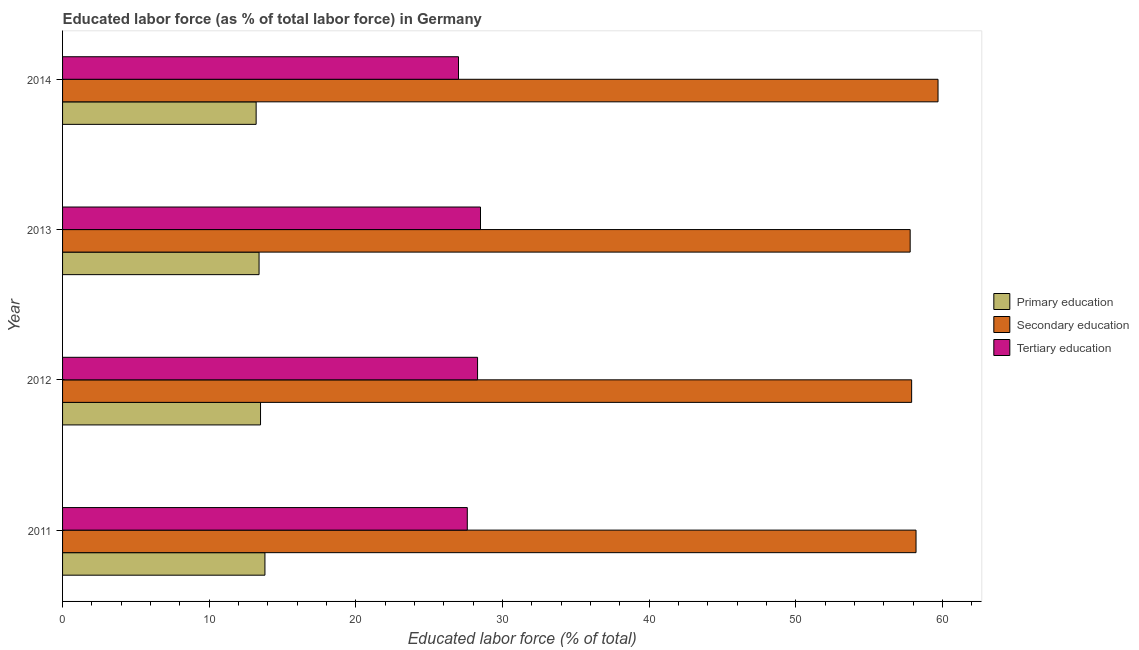How many different coloured bars are there?
Your response must be concise. 3. Are the number of bars per tick equal to the number of legend labels?
Your answer should be compact. Yes. Are the number of bars on each tick of the Y-axis equal?
Ensure brevity in your answer.  Yes. How many bars are there on the 1st tick from the top?
Keep it short and to the point. 3. In how many cases, is the number of bars for a given year not equal to the number of legend labels?
Offer a terse response. 0. What is the percentage of labor force who received secondary education in 2014?
Provide a succinct answer. 59.7. Across all years, what is the maximum percentage of labor force who received secondary education?
Offer a very short reply. 59.7. In which year was the percentage of labor force who received primary education minimum?
Make the answer very short. 2014. What is the total percentage of labor force who received secondary education in the graph?
Your answer should be compact. 233.6. What is the difference between the percentage of labor force who received primary education in 2011 and the percentage of labor force who received secondary education in 2013?
Your answer should be compact. -44. What is the average percentage of labor force who received tertiary education per year?
Offer a terse response. 27.85. In the year 2013, what is the difference between the percentage of labor force who received primary education and percentage of labor force who received tertiary education?
Your response must be concise. -15.1. In how many years, is the percentage of labor force who received tertiary education greater than 16 %?
Your answer should be compact. 4. What is the difference between the highest and the lowest percentage of labor force who received primary education?
Your answer should be compact. 0.6. In how many years, is the percentage of labor force who received tertiary education greater than the average percentage of labor force who received tertiary education taken over all years?
Offer a very short reply. 2. Is the sum of the percentage of labor force who received secondary education in 2012 and 2013 greater than the maximum percentage of labor force who received primary education across all years?
Keep it short and to the point. Yes. What does the 3rd bar from the top in 2014 represents?
Give a very brief answer. Primary education. What does the 2nd bar from the bottom in 2011 represents?
Offer a very short reply. Secondary education. How many bars are there?
Make the answer very short. 12. How many years are there in the graph?
Ensure brevity in your answer.  4. Does the graph contain grids?
Keep it short and to the point. No. Where does the legend appear in the graph?
Provide a succinct answer. Center right. How are the legend labels stacked?
Keep it short and to the point. Vertical. What is the title of the graph?
Provide a short and direct response. Educated labor force (as % of total labor force) in Germany. Does "Secondary" appear as one of the legend labels in the graph?
Make the answer very short. No. What is the label or title of the X-axis?
Give a very brief answer. Educated labor force (% of total). What is the label or title of the Y-axis?
Offer a very short reply. Year. What is the Educated labor force (% of total) of Primary education in 2011?
Provide a succinct answer. 13.8. What is the Educated labor force (% of total) in Secondary education in 2011?
Offer a terse response. 58.2. What is the Educated labor force (% of total) in Tertiary education in 2011?
Give a very brief answer. 27.6. What is the Educated labor force (% of total) in Primary education in 2012?
Your answer should be very brief. 13.5. What is the Educated labor force (% of total) of Secondary education in 2012?
Ensure brevity in your answer.  57.9. What is the Educated labor force (% of total) in Tertiary education in 2012?
Ensure brevity in your answer.  28.3. What is the Educated labor force (% of total) in Primary education in 2013?
Keep it short and to the point. 13.4. What is the Educated labor force (% of total) of Secondary education in 2013?
Your response must be concise. 57.8. What is the Educated labor force (% of total) in Tertiary education in 2013?
Make the answer very short. 28.5. What is the Educated labor force (% of total) in Primary education in 2014?
Make the answer very short. 13.2. What is the Educated labor force (% of total) in Secondary education in 2014?
Provide a succinct answer. 59.7. What is the Educated labor force (% of total) of Tertiary education in 2014?
Offer a terse response. 27. Across all years, what is the maximum Educated labor force (% of total) in Primary education?
Ensure brevity in your answer.  13.8. Across all years, what is the maximum Educated labor force (% of total) in Secondary education?
Give a very brief answer. 59.7. Across all years, what is the minimum Educated labor force (% of total) of Primary education?
Your answer should be compact. 13.2. Across all years, what is the minimum Educated labor force (% of total) of Secondary education?
Your answer should be very brief. 57.8. Across all years, what is the minimum Educated labor force (% of total) of Tertiary education?
Ensure brevity in your answer.  27. What is the total Educated labor force (% of total) in Primary education in the graph?
Offer a terse response. 53.9. What is the total Educated labor force (% of total) of Secondary education in the graph?
Your answer should be compact. 233.6. What is the total Educated labor force (% of total) in Tertiary education in the graph?
Your answer should be compact. 111.4. What is the difference between the Educated labor force (% of total) of Primary education in 2011 and that in 2012?
Provide a short and direct response. 0.3. What is the difference between the Educated labor force (% of total) of Secondary education in 2011 and that in 2013?
Offer a very short reply. 0.4. What is the difference between the Educated labor force (% of total) in Primary education in 2011 and that in 2014?
Provide a short and direct response. 0.6. What is the difference between the Educated labor force (% of total) in Secondary education in 2011 and that in 2014?
Provide a succinct answer. -1.5. What is the difference between the Educated labor force (% of total) in Primary education in 2013 and that in 2014?
Your answer should be very brief. 0.2. What is the difference between the Educated labor force (% of total) in Tertiary education in 2013 and that in 2014?
Provide a short and direct response. 1.5. What is the difference between the Educated labor force (% of total) in Primary education in 2011 and the Educated labor force (% of total) in Secondary education in 2012?
Your response must be concise. -44.1. What is the difference between the Educated labor force (% of total) of Primary education in 2011 and the Educated labor force (% of total) of Tertiary education in 2012?
Offer a terse response. -14.5. What is the difference between the Educated labor force (% of total) in Secondary education in 2011 and the Educated labor force (% of total) in Tertiary education in 2012?
Your response must be concise. 29.9. What is the difference between the Educated labor force (% of total) in Primary education in 2011 and the Educated labor force (% of total) in Secondary education in 2013?
Your answer should be compact. -44. What is the difference between the Educated labor force (% of total) in Primary education in 2011 and the Educated labor force (% of total) in Tertiary education in 2013?
Offer a very short reply. -14.7. What is the difference between the Educated labor force (% of total) in Secondary education in 2011 and the Educated labor force (% of total) in Tertiary education in 2013?
Your answer should be compact. 29.7. What is the difference between the Educated labor force (% of total) of Primary education in 2011 and the Educated labor force (% of total) of Secondary education in 2014?
Provide a succinct answer. -45.9. What is the difference between the Educated labor force (% of total) of Primary education in 2011 and the Educated labor force (% of total) of Tertiary education in 2014?
Keep it short and to the point. -13.2. What is the difference between the Educated labor force (% of total) in Secondary education in 2011 and the Educated labor force (% of total) in Tertiary education in 2014?
Make the answer very short. 31.2. What is the difference between the Educated labor force (% of total) of Primary education in 2012 and the Educated labor force (% of total) of Secondary education in 2013?
Give a very brief answer. -44.3. What is the difference between the Educated labor force (% of total) in Primary education in 2012 and the Educated labor force (% of total) in Tertiary education in 2013?
Make the answer very short. -15. What is the difference between the Educated labor force (% of total) of Secondary education in 2012 and the Educated labor force (% of total) of Tertiary education in 2013?
Provide a succinct answer. 29.4. What is the difference between the Educated labor force (% of total) of Primary education in 2012 and the Educated labor force (% of total) of Secondary education in 2014?
Provide a succinct answer. -46.2. What is the difference between the Educated labor force (% of total) in Secondary education in 2012 and the Educated labor force (% of total) in Tertiary education in 2014?
Make the answer very short. 30.9. What is the difference between the Educated labor force (% of total) of Primary education in 2013 and the Educated labor force (% of total) of Secondary education in 2014?
Your answer should be compact. -46.3. What is the difference between the Educated labor force (% of total) in Primary education in 2013 and the Educated labor force (% of total) in Tertiary education in 2014?
Your answer should be compact. -13.6. What is the difference between the Educated labor force (% of total) in Secondary education in 2013 and the Educated labor force (% of total) in Tertiary education in 2014?
Offer a very short reply. 30.8. What is the average Educated labor force (% of total) in Primary education per year?
Your response must be concise. 13.47. What is the average Educated labor force (% of total) of Secondary education per year?
Your response must be concise. 58.4. What is the average Educated labor force (% of total) of Tertiary education per year?
Make the answer very short. 27.85. In the year 2011, what is the difference between the Educated labor force (% of total) of Primary education and Educated labor force (% of total) of Secondary education?
Make the answer very short. -44.4. In the year 2011, what is the difference between the Educated labor force (% of total) in Secondary education and Educated labor force (% of total) in Tertiary education?
Your answer should be compact. 30.6. In the year 2012, what is the difference between the Educated labor force (% of total) in Primary education and Educated labor force (% of total) in Secondary education?
Your response must be concise. -44.4. In the year 2012, what is the difference between the Educated labor force (% of total) in Primary education and Educated labor force (% of total) in Tertiary education?
Provide a short and direct response. -14.8. In the year 2012, what is the difference between the Educated labor force (% of total) in Secondary education and Educated labor force (% of total) in Tertiary education?
Offer a very short reply. 29.6. In the year 2013, what is the difference between the Educated labor force (% of total) in Primary education and Educated labor force (% of total) in Secondary education?
Your response must be concise. -44.4. In the year 2013, what is the difference between the Educated labor force (% of total) of Primary education and Educated labor force (% of total) of Tertiary education?
Your response must be concise. -15.1. In the year 2013, what is the difference between the Educated labor force (% of total) of Secondary education and Educated labor force (% of total) of Tertiary education?
Provide a short and direct response. 29.3. In the year 2014, what is the difference between the Educated labor force (% of total) of Primary education and Educated labor force (% of total) of Secondary education?
Make the answer very short. -46.5. In the year 2014, what is the difference between the Educated labor force (% of total) in Primary education and Educated labor force (% of total) in Tertiary education?
Your answer should be compact. -13.8. In the year 2014, what is the difference between the Educated labor force (% of total) of Secondary education and Educated labor force (% of total) of Tertiary education?
Provide a short and direct response. 32.7. What is the ratio of the Educated labor force (% of total) in Primary education in 2011 to that in 2012?
Keep it short and to the point. 1.02. What is the ratio of the Educated labor force (% of total) in Tertiary education in 2011 to that in 2012?
Give a very brief answer. 0.98. What is the ratio of the Educated labor force (% of total) in Primary education in 2011 to that in 2013?
Make the answer very short. 1.03. What is the ratio of the Educated labor force (% of total) in Secondary education in 2011 to that in 2013?
Your response must be concise. 1.01. What is the ratio of the Educated labor force (% of total) of Tertiary education in 2011 to that in 2013?
Provide a succinct answer. 0.97. What is the ratio of the Educated labor force (% of total) of Primary education in 2011 to that in 2014?
Make the answer very short. 1.05. What is the ratio of the Educated labor force (% of total) of Secondary education in 2011 to that in 2014?
Offer a very short reply. 0.97. What is the ratio of the Educated labor force (% of total) of Tertiary education in 2011 to that in 2014?
Your response must be concise. 1.02. What is the ratio of the Educated labor force (% of total) of Primary education in 2012 to that in 2013?
Provide a short and direct response. 1.01. What is the ratio of the Educated labor force (% of total) of Tertiary education in 2012 to that in 2013?
Offer a terse response. 0.99. What is the ratio of the Educated labor force (% of total) of Primary education in 2012 to that in 2014?
Your answer should be very brief. 1.02. What is the ratio of the Educated labor force (% of total) of Secondary education in 2012 to that in 2014?
Your answer should be very brief. 0.97. What is the ratio of the Educated labor force (% of total) of Tertiary education in 2012 to that in 2014?
Keep it short and to the point. 1.05. What is the ratio of the Educated labor force (% of total) in Primary education in 2013 to that in 2014?
Ensure brevity in your answer.  1.02. What is the ratio of the Educated labor force (% of total) in Secondary education in 2013 to that in 2014?
Provide a short and direct response. 0.97. What is the ratio of the Educated labor force (% of total) in Tertiary education in 2013 to that in 2014?
Your answer should be compact. 1.06. What is the difference between the highest and the second highest Educated labor force (% of total) of Primary education?
Ensure brevity in your answer.  0.3. What is the difference between the highest and the lowest Educated labor force (% of total) of Primary education?
Keep it short and to the point. 0.6. What is the difference between the highest and the lowest Educated labor force (% of total) of Tertiary education?
Provide a short and direct response. 1.5. 